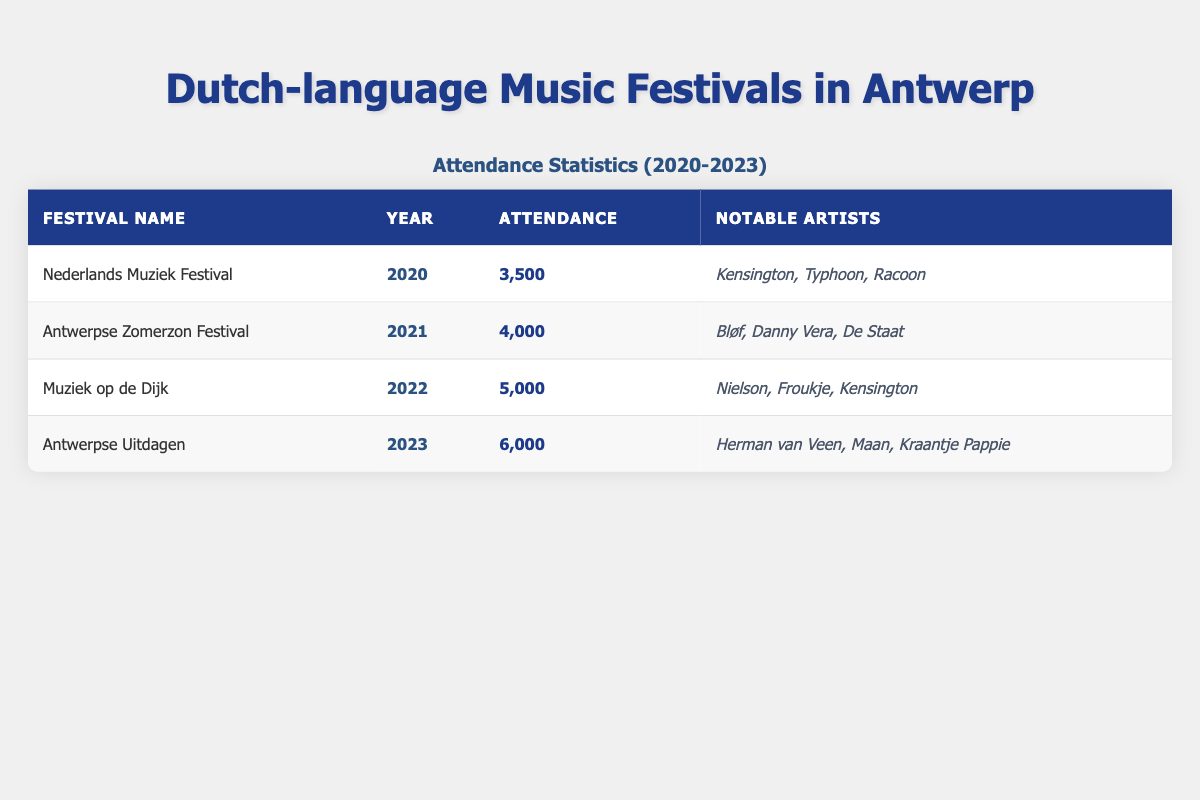What is the attendance for the Antwerpse Zomerzon Festival in 2021? The table shows the attendance for the Antwerpse Zomerzon Festival in 2021 as 4,000.
Answer: 4,000 Which year had the highest attendance? By comparing the attendance values from each year, the highest attendance is 6,000 in 2023 for the Antwerpse Uitdagen festival.
Answer: 2023 How many notable artists performed at the Muziek op de Dijk in 2022? The table indicates that there are three notable artists listed for Muziek op de Dijk in 2022: Nielson, Froukje, and Kensington.
Answer: 3 What is the total attendance from 2020 to 2023? The total attendance is calculated by adding the individual attendance numbers: 3,500 (2020) + 4,000 (2021) + 5,000 (2022) + 6,000 (2023) = 18,500.
Answer: 18,500 Did the attendance increase every year from 2020 to 2023? By examining the attendance values, we can see that attendance increased from 3,500 in 2020 to 4,000 in 2021, then to 5,000 in 2022, and finally to 6,000 in 2023, confirming that attendance increased every year.
Answer: Yes What was the average attendance over the four years? To find the average attendance, we sum the attendance values (3,500 + 4,000 + 5,000 + 6,000 = 18,500) and then divide by the number of years (4): 18,500 / 4 = 4,625.
Answer: 4,625 Which festival featured Kensington as a notable artist in 2022? The table lists the Muziek op de Dijk festival in 2022, which includes Kensington among its notable artists.
Answer: Muziek op de Dijk How many years had an attendance of more than 4,000? The attendance values for 2021 (4,000), 2022 (5,000), and 2023 (6,000) show that two years (2022 and 2023) had attendance greater than 4,000.
Answer: 2 Is there a notable artist from the Antwerpse Uitdagen in 2023? The table includes Herman van Veen, Maan, and Kraantje Pappie as notable artists for the Antwerpse Uitdagen in 2023, confirming that there are notable artists for this festival.
Answer: Yes What is the difference in attendance between the Nederlands Muziek Festival in 2020 and the Antwerpse Uitdagen in 2023? The attendance for the Nederlands Muziek Festival in 2020 is 3,500 and for the Antwerpse Uitdagen in 2023 is 6,000. The difference is 6,000 - 3,500 = 2,500.
Answer: 2,500 Which festival had the least attendance and who were the notable artists? According to the table, the festival with the least attendance is the Nederlands Muziek Festival in 2020 with an attendance of 3,500, and the notable artists were Kensington, Typhoon, and Racoon.
Answer: Nederlands Muziek Festival, Kensington, Typhoon, Racoon 